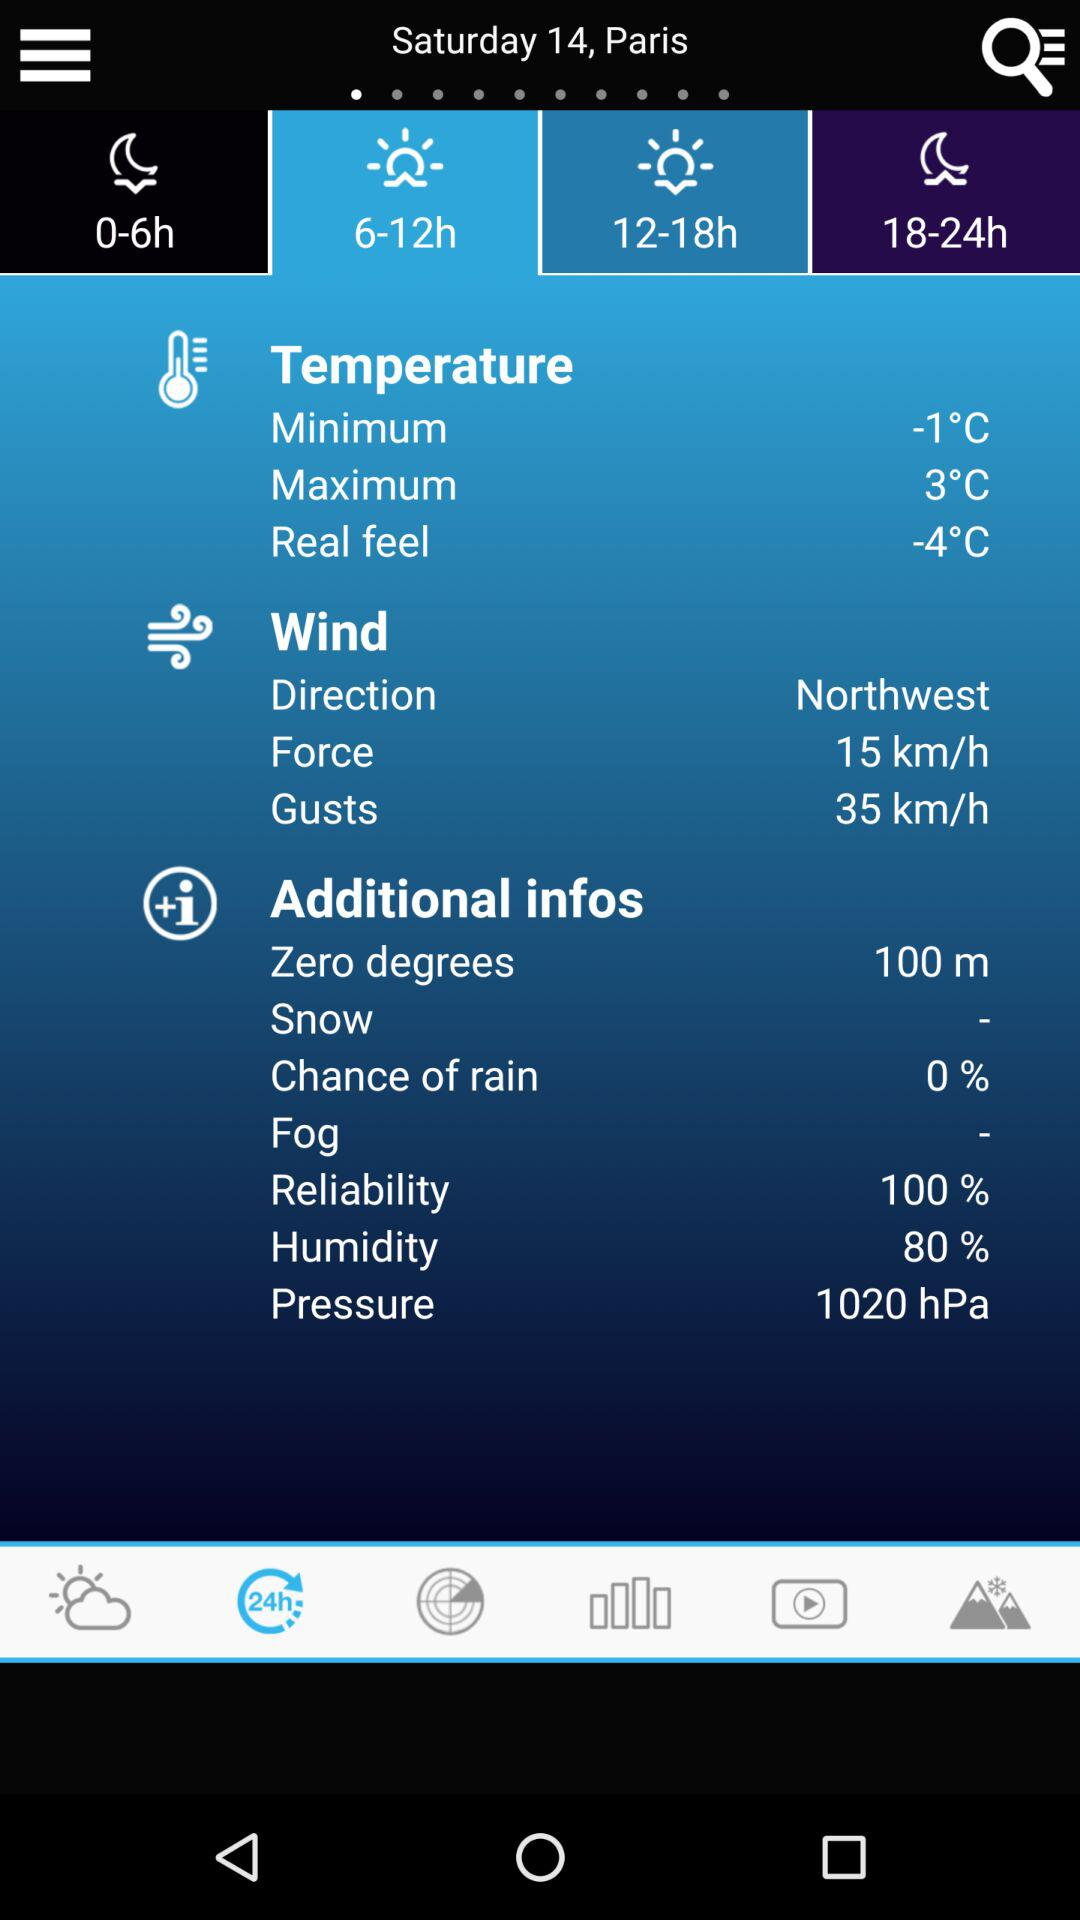What is the direction of the wind? The direction of the wind is northwest. 